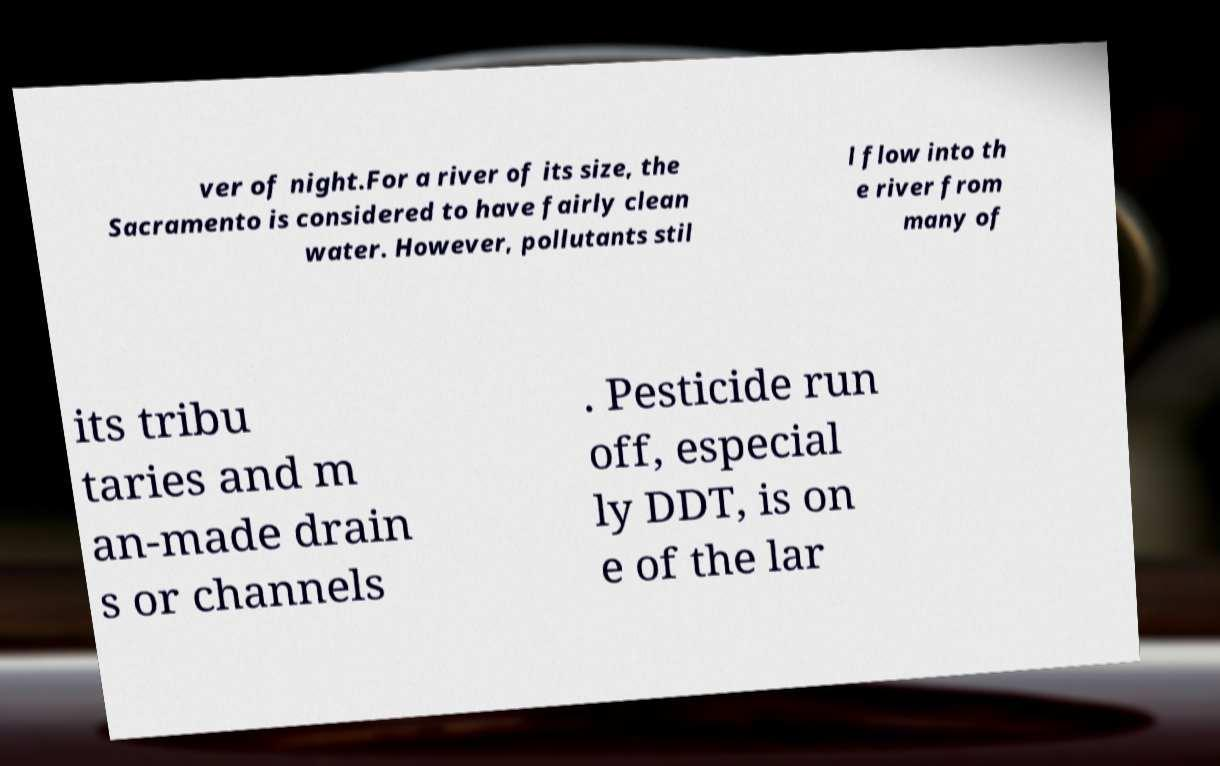Can you read and provide the text displayed in the image?This photo seems to have some interesting text. Can you extract and type it out for me? ver of night.For a river of its size, the Sacramento is considered to have fairly clean water. However, pollutants stil l flow into th e river from many of its tribu taries and m an-made drain s or channels . Pesticide run off, especial ly DDT, is on e of the lar 